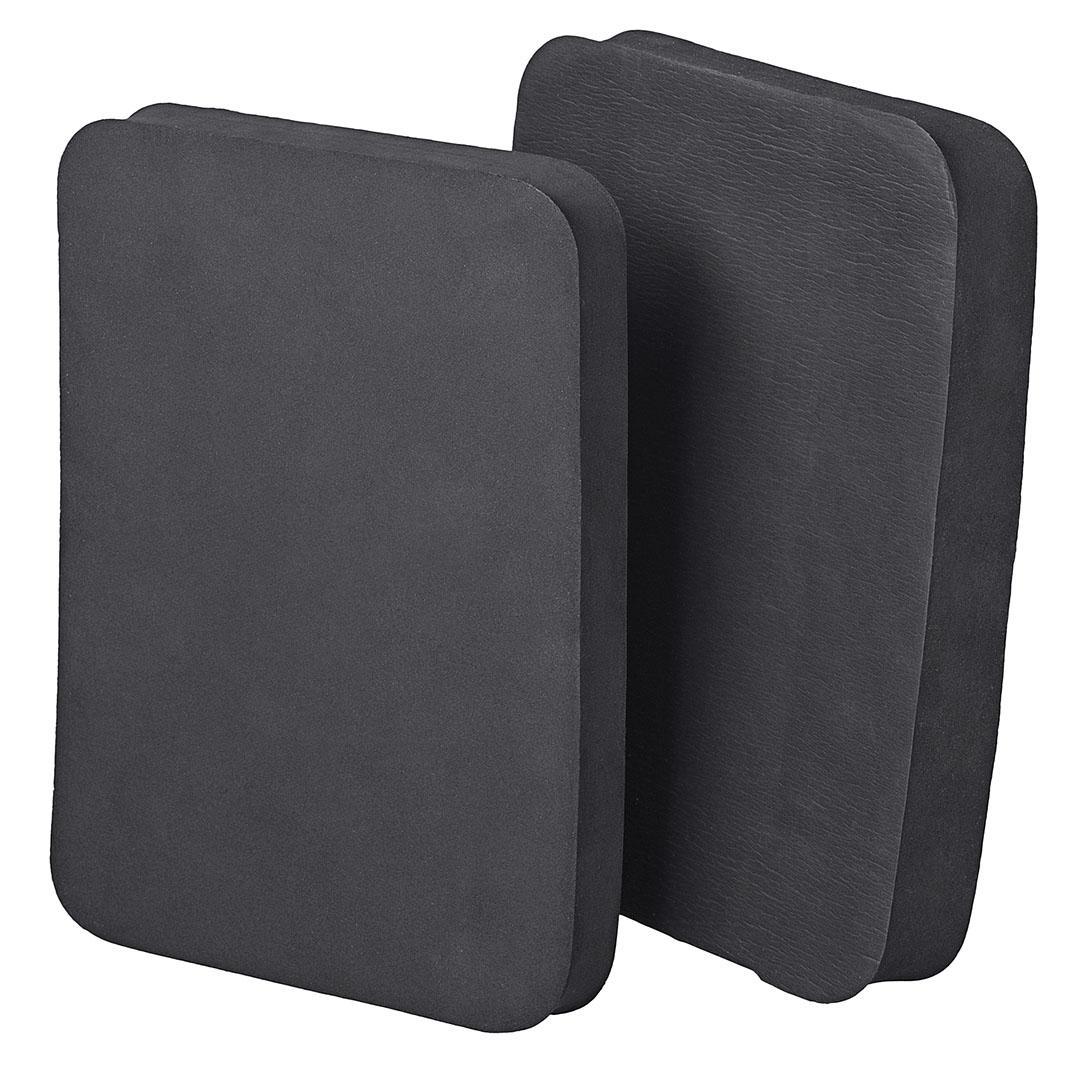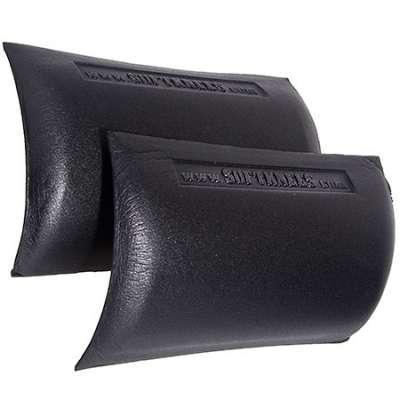The first image is the image on the left, the second image is the image on the right. For the images shown, is this caption "At least one of the knee pads is textured." true? Answer yes or no. No. The first image is the image on the left, the second image is the image on the right. For the images displayed, is the sentence "An image shows a notched kneepad, with slits at the sides." factually correct? Answer yes or no. No. 